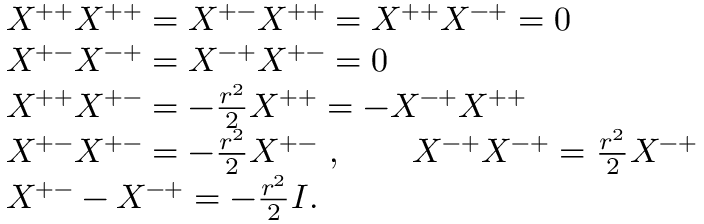<formula> <loc_0><loc_0><loc_500><loc_500>\begin{array} { r l & { { X ^ { + + } X ^ { + + } = X ^ { + - } X ^ { + + } = X ^ { + + } X ^ { - + } = 0 } } & { { X ^ { + - } X ^ { - + } = X ^ { - + } X ^ { + - } = 0 } } & { { X ^ { + + } X ^ { + - } = - { \frac { r ^ { 2 } } { 2 } } X ^ { + + } = - X ^ { - + } X ^ { + + } } } & { { X ^ { + - } X ^ { + - } = - { \frac { r ^ { 2 } } { 2 } } X ^ { + - } \ , \quad X ^ { - + } X ^ { - + } = { \frac { r ^ { 2 } } { 2 } } X ^ { - + } } } & { { X ^ { + - } - X ^ { - + } = - { \frac { r ^ { 2 } } { 2 } } I . } } \end{array}</formula> 